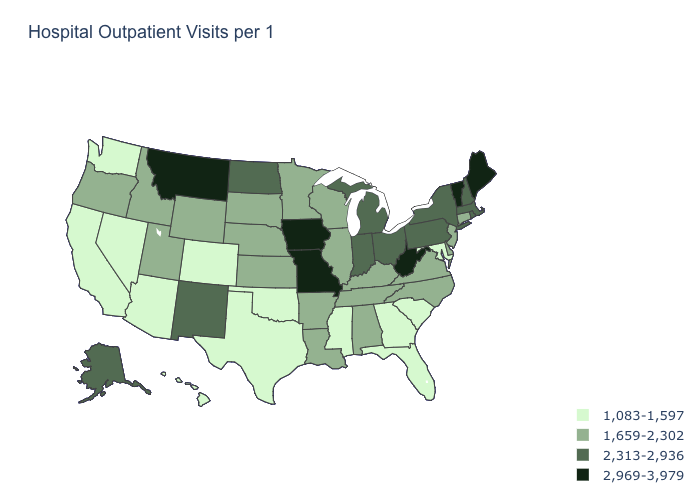What is the value of Nebraska?
Write a very short answer. 1,659-2,302. Does Maine have the same value as Missouri?
Quick response, please. Yes. Name the states that have a value in the range 2,969-3,979?
Quick response, please. Iowa, Maine, Missouri, Montana, Vermont, West Virginia. What is the value of Maine?
Answer briefly. 2,969-3,979. Name the states that have a value in the range 1,083-1,597?
Quick response, please. Arizona, California, Colorado, Florida, Georgia, Hawaii, Maryland, Mississippi, Nevada, Oklahoma, South Carolina, Texas, Washington. What is the value of New Jersey?
Write a very short answer. 1,659-2,302. What is the value of Kansas?
Short answer required. 1,659-2,302. Among the states that border Michigan , which have the lowest value?
Write a very short answer. Wisconsin. Which states have the highest value in the USA?
Short answer required. Iowa, Maine, Missouri, Montana, Vermont, West Virginia. Name the states that have a value in the range 2,313-2,936?
Give a very brief answer. Alaska, Indiana, Massachusetts, Michigan, New Hampshire, New Mexico, New York, North Dakota, Ohio, Pennsylvania, Rhode Island. Name the states that have a value in the range 2,313-2,936?
Concise answer only. Alaska, Indiana, Massachusetts, Michigan, New Hampshire, New Mexico, New York, North Dakota, Ohio, Pennsylvania, Rhode Island. Does Mississippi have the highest value in the USA?
Answer briefly. No. Name the states that have a value in the range 2,313-2,936?
Quick response, please. Alaska, Indiana, Massachusetts, Michigan, New Hampshire, New Mexico, New York, North Dakota, Ohio, Pennsylvania, Rhode Island. Name the states that have a value in the range 1,083-1,597?
Answer briefly. Arizona, California, Colorado, Florida, Georgia, Hawaii, Maryland, Mississippi, Nevada, Oklahoma, South Carolina, Texas, Washington. What is the highest value in the USA?
Short answer required. 2,969-3,979. 